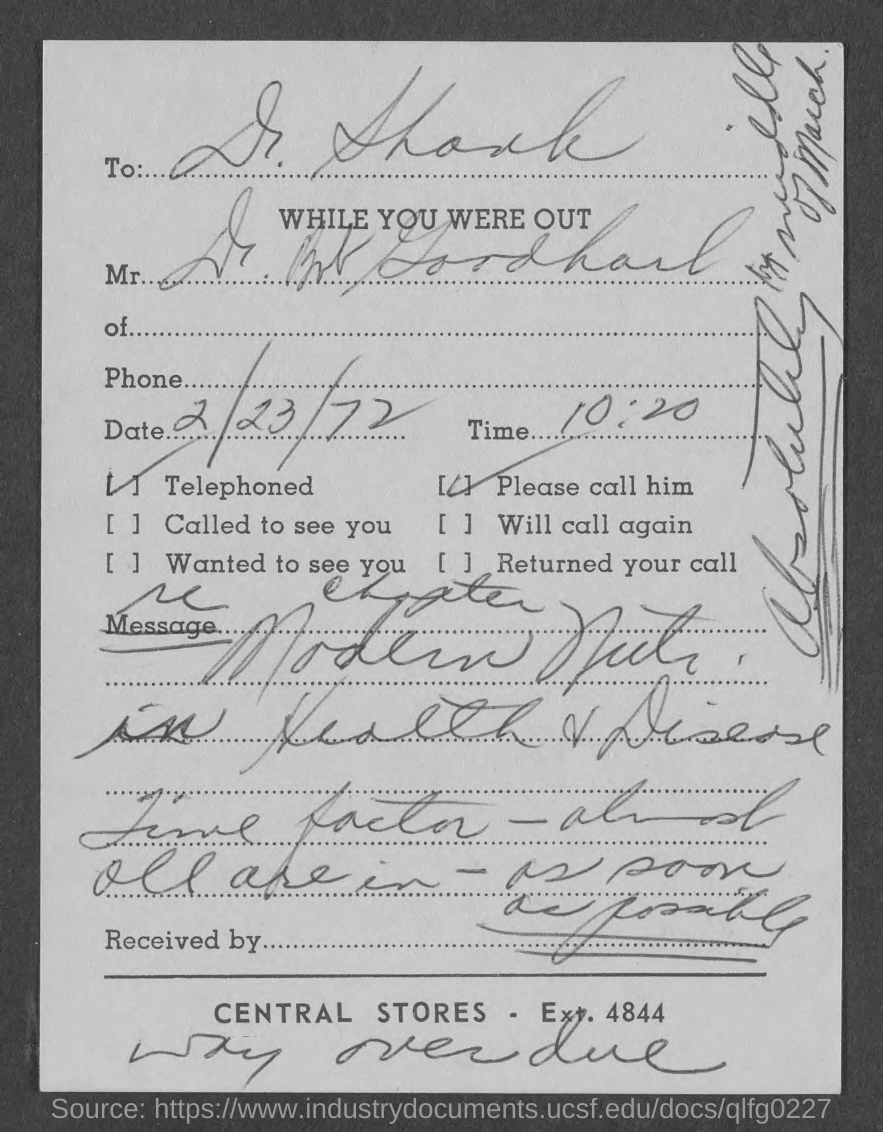Draw attention to some important aspects in this diagram. This document mentions a time of 10:20. The document is addressed to Dr. Shank. The document contains a date of February 23, 1972. 